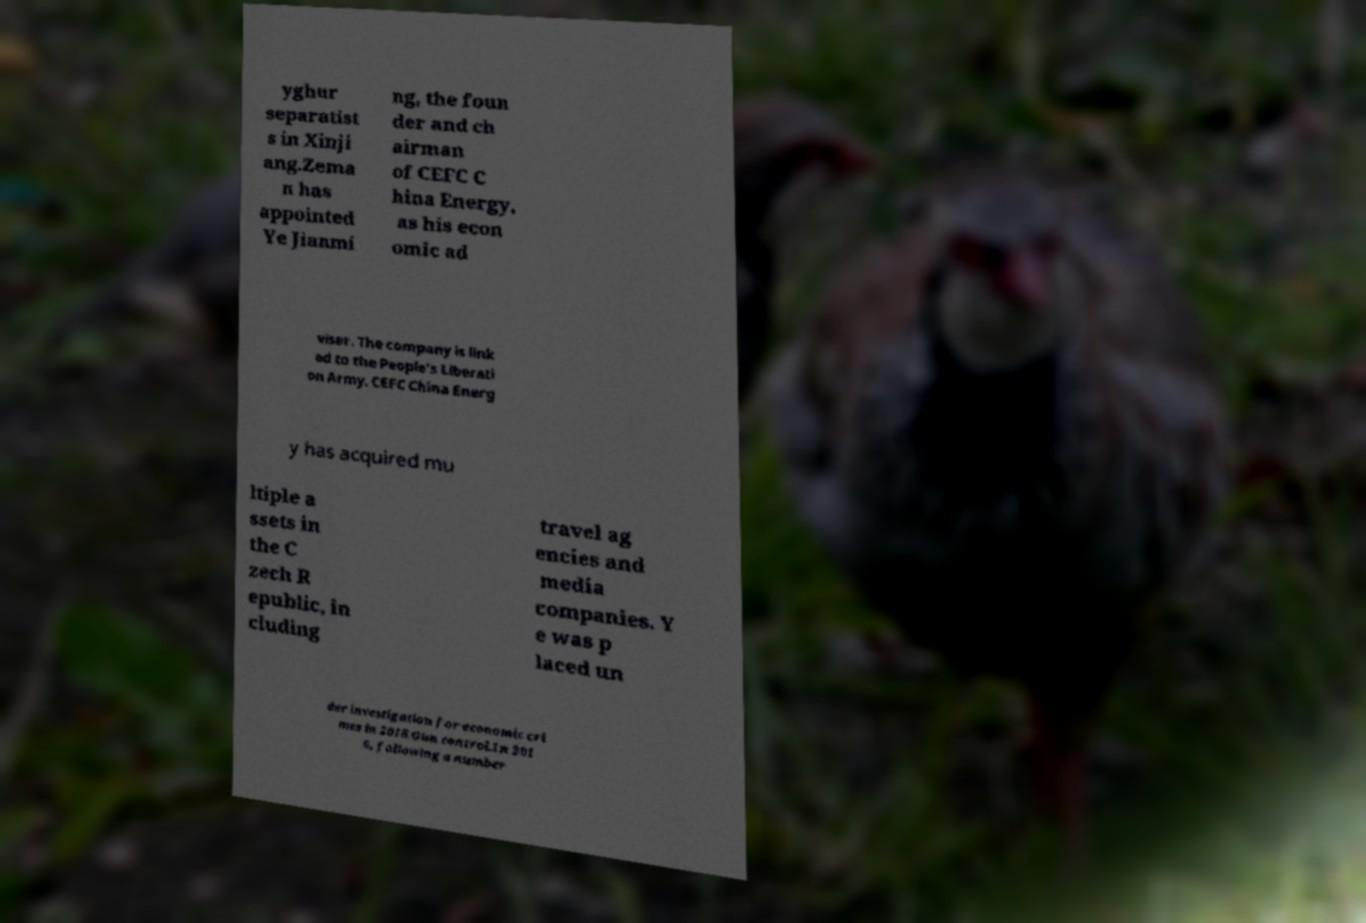For documentation purposes, I need the text within this image transcribed. Could you provide that? yghur separatist s in Xinji ang.Zema n has appointed Ye Jianmi ng, the foun der and ch airman of CEFC C hina Energy, as his econ omic ad viser. The company is link ed to the People's Liberati on Army. CEFC China Energ y has acquired mu ltiple a ssets in the C zech R epublic, in cluding travel ag encies and media companies. Y e was p laced un der investigation for economic cri mes in 2018.Gun control.In 201 6, following a number 